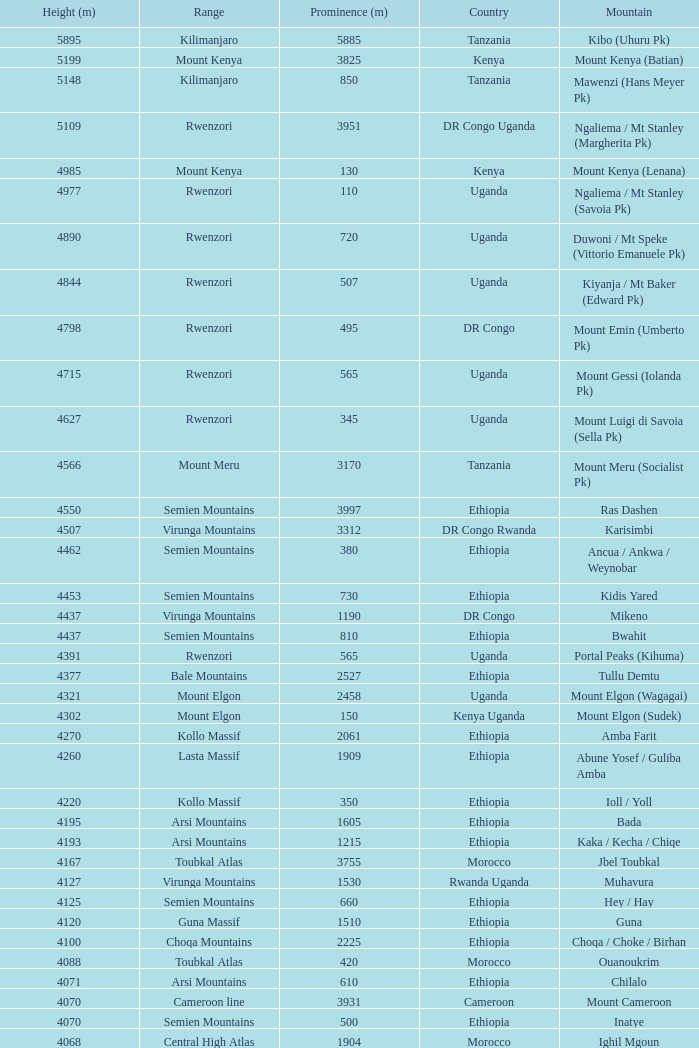Which Country has a Prominence (m) smaller than 1540, and a Height (m) smaller than 3530, and a Range of virunga mountains, and a Mountain of nyiragongo? DR Congo. 